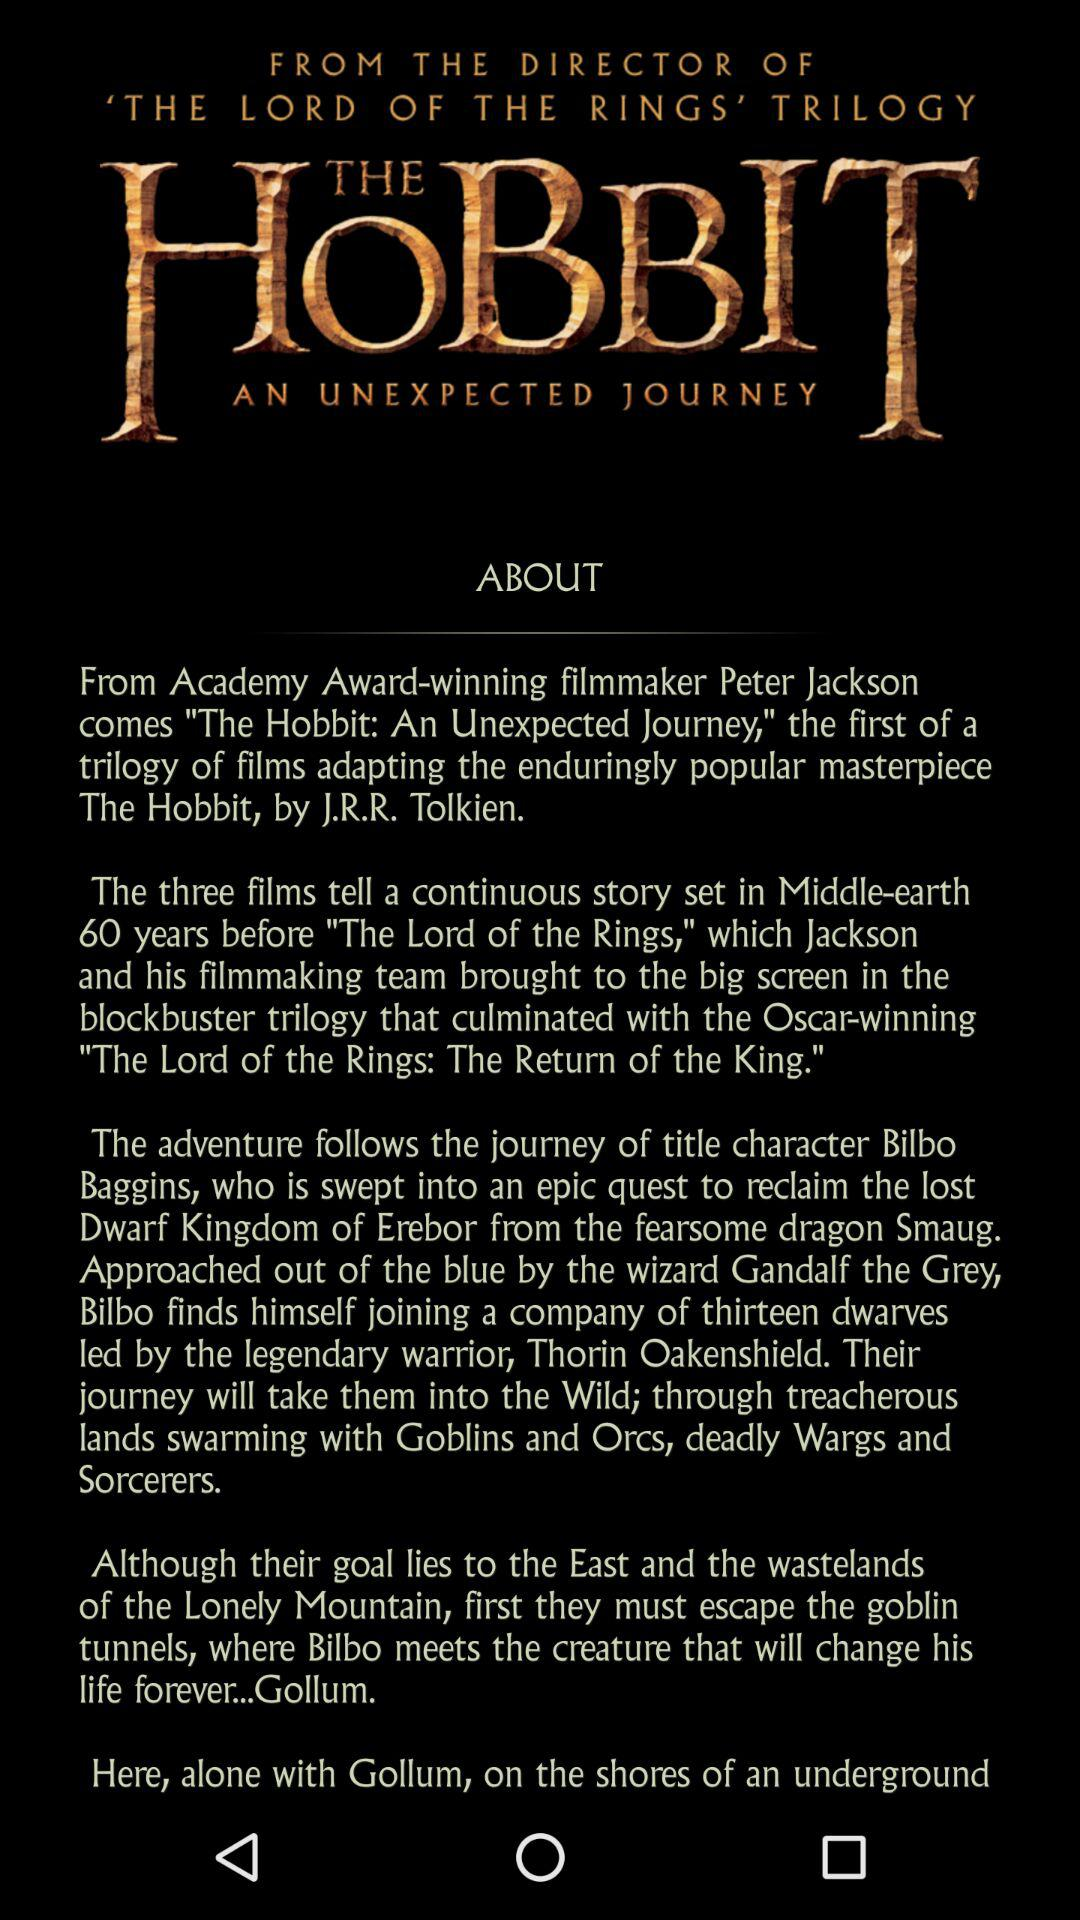What is the movie name? The movie names are "The Hobbit: An Unexpected Journey" and "The Lord of the Rings: The Return of the King". 